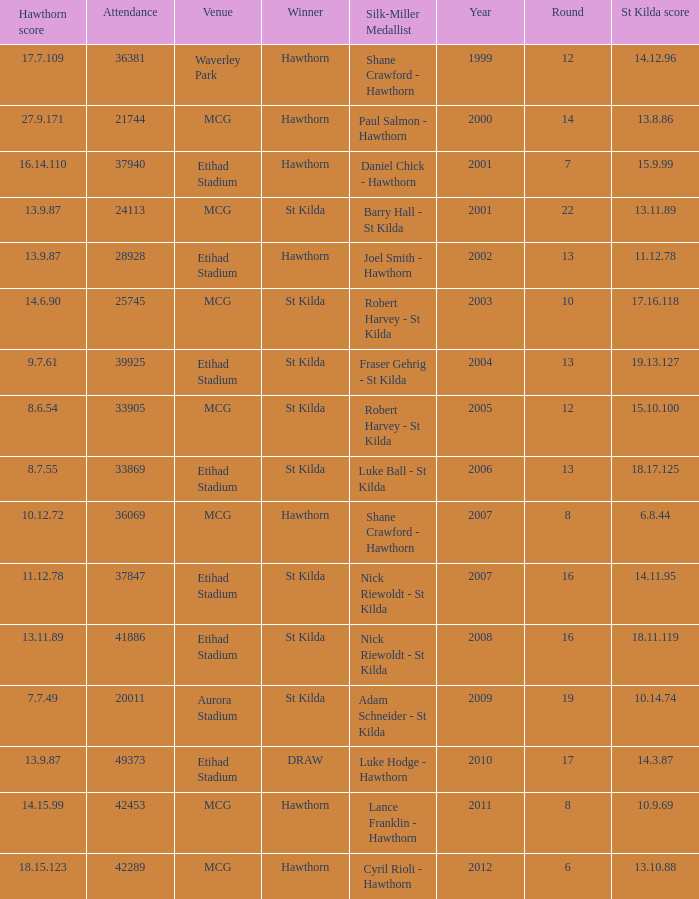Who is the winner when the st kilda score is 13.10.88? Hawthorn. 